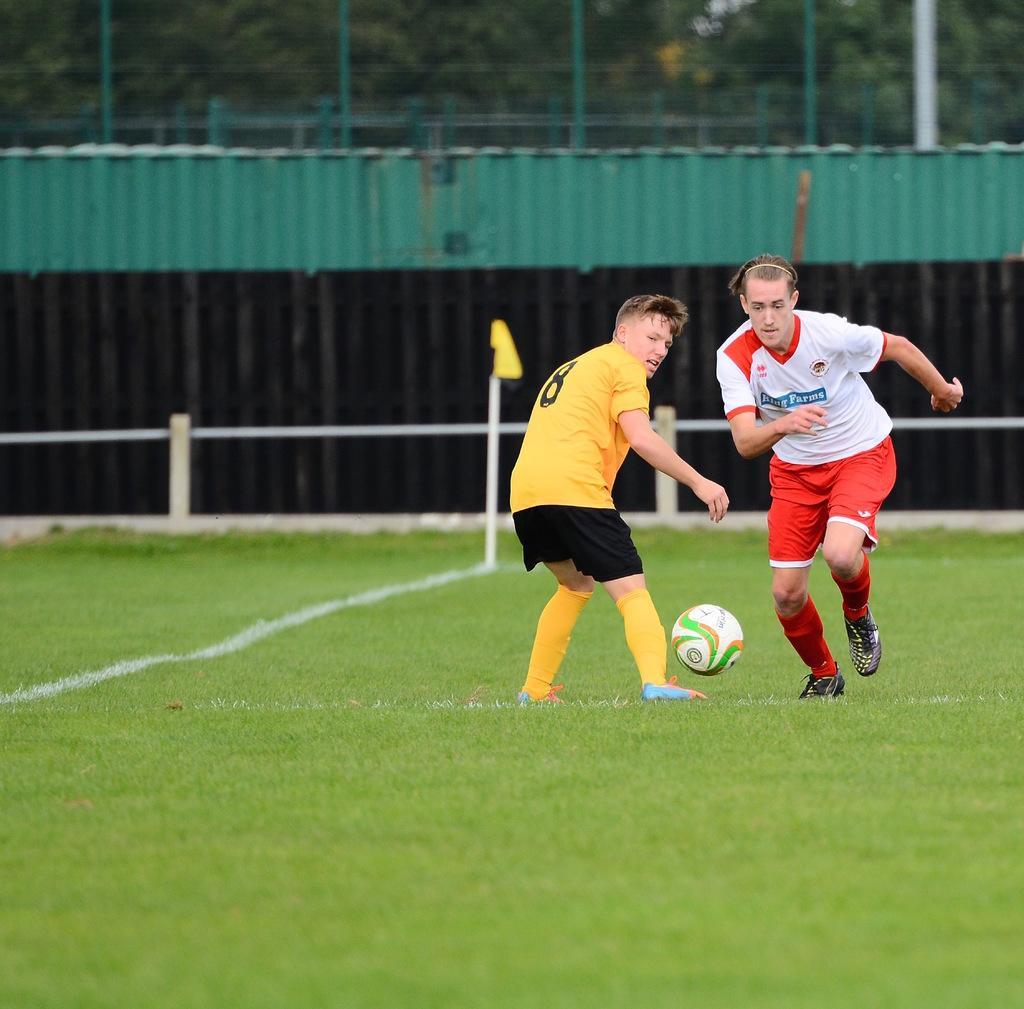In one or two sentences, can you explain what this image depicts? In this image I can see two people are on the ground. These people are wearing the yellow and black and red and white color dress. I can see there is a ball on the ground. In the back I can see the railing and the green color bridge. I can also see the trees in the back. 